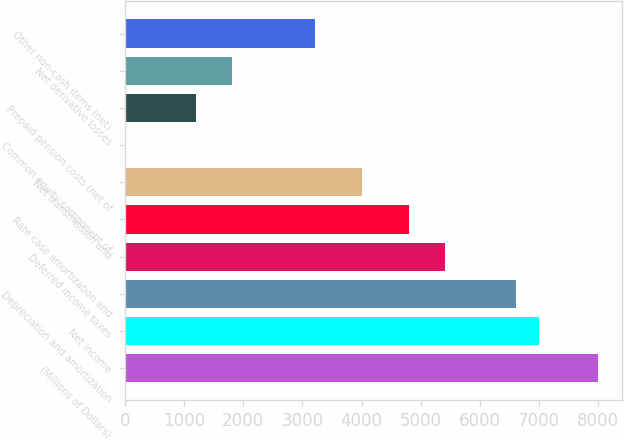Convert chart to OTSL. <chart><loc_0><loc_0><loc_500><loc_500><bar_chart><fcel>(Millions of Dollars)<fcel>Net Income<fcel>Depreciation and amortization<fcel>Deferred income taxes<fcel>Rate case amortization and<fcel>Net transmission and<fcel>Common equity component of<fcel>Prepaid pension costs (net of<fcel>Net derivative losses<fcel>Other non-cash items (net)<nl><fcel>8006<fcel>7006<fcel>6606<fcel>5406<fcel>4806<fcel>4006<fcel>6<fcel>1206<fcel>1806<fcel>3206<nl></chart> 